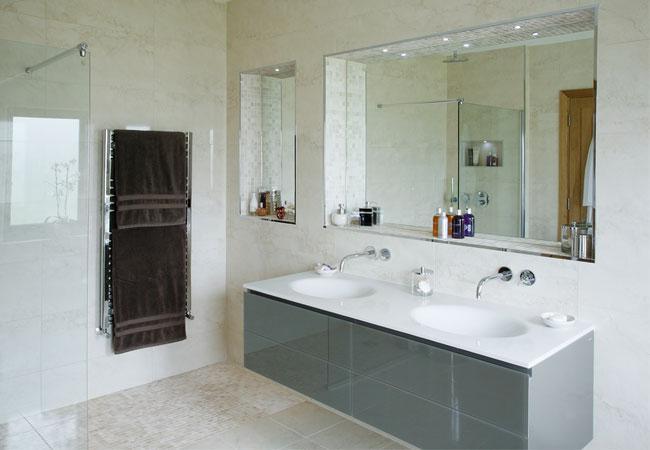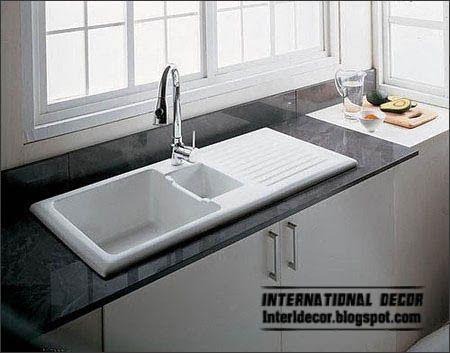The first image is the image on the left, the second image is the image on the right. Considering the images on both sides, is "The sink in one of the images is set into a brown wood hanging counter." valid? Answer yes or no. No. The first image is the image on the left, the second image is the image on the right. Given the left and right images, does the statement "A jar of fernlike foliage and a leaning framed picture are next to a rectangular gray sink mounted on a wood plank." hold true? Answer yes or no. No. 